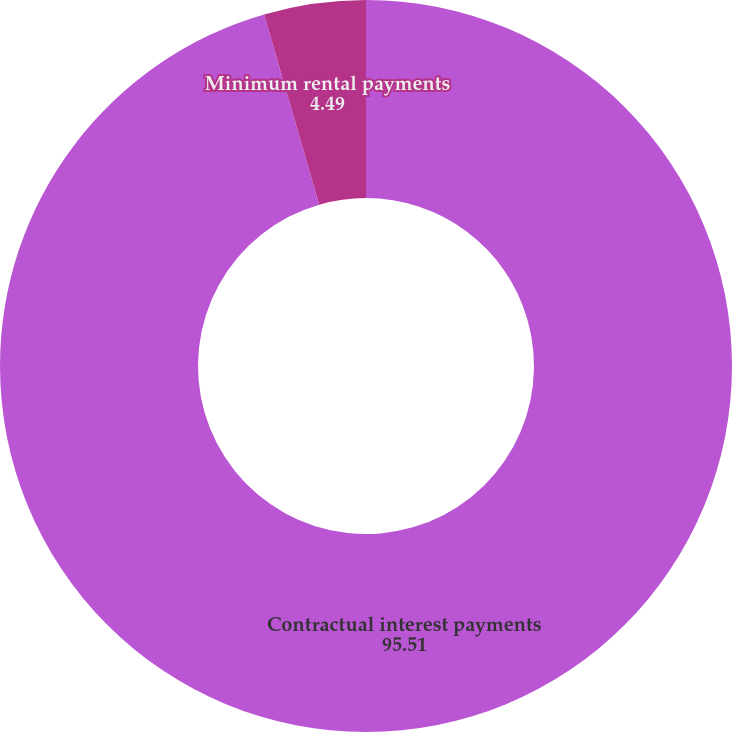Convert chart. <chart><loc_0><loc_0><loc_500><loc_500><pie_chart><fcel>Contractual interest payments<fcel>Minimum rental payments<nl><fcel>95.51%<fcel>4.49%<nl></chart> 